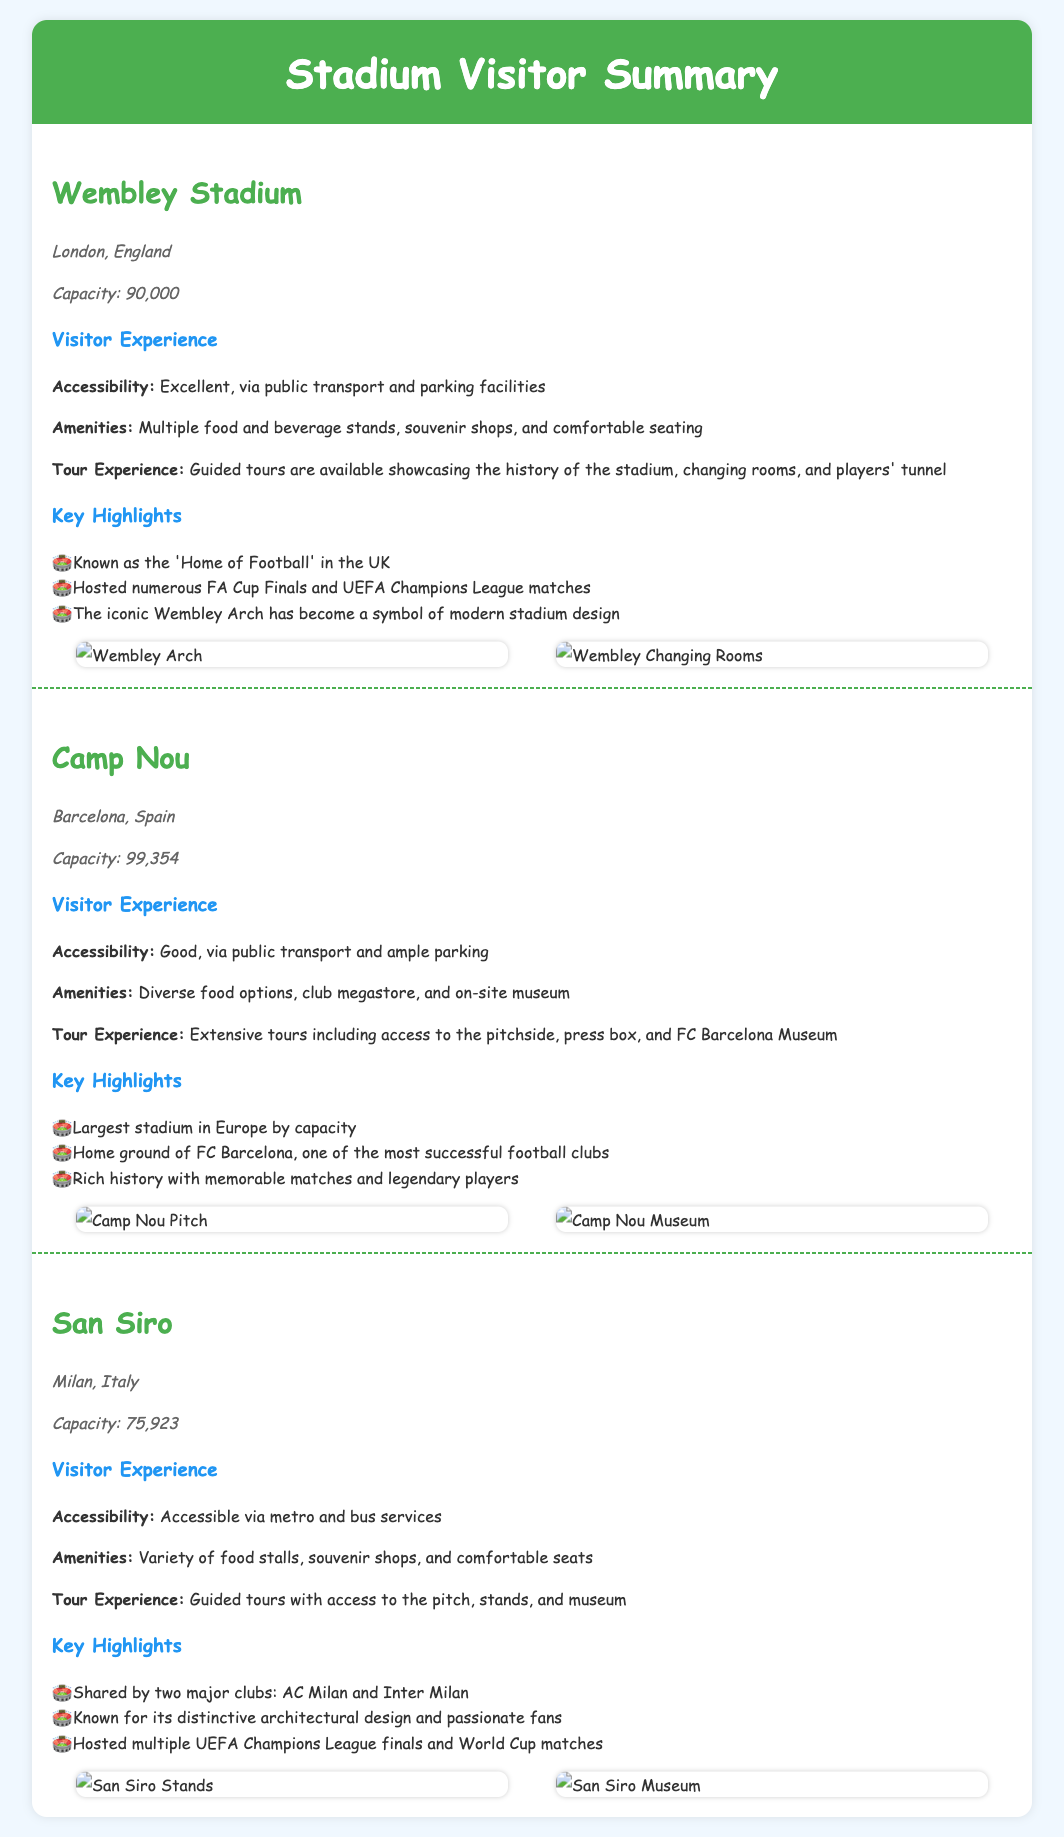What is the capacity of Wembley Stadium? The capacity of Wembley Stadium is explicitly mentioned as 90,000 in the document.
Answer: 90,000 Where is Camp Nou located? The location of Camp Nou is specified as Barcelona, Spain in the document.
Answer: Barcelona, Spain How many clubs share the San Siro? The document states that San Siro is shared by two major clubs, AC Milan and Inter Milan.
Answer: Two What is a key highlight of Wembley Stadium? The document lists memorable highlights of Wembley Stadium, emphasizing its status as the 'Home of Football' in the UK.
Answer: Home of Football What is an amenity available at Camp Nou? The document mentions that Camp Nou has a club megastore among its amenities.
Answer: Club megastore What type of tours are available at San Siro? Guided tours are available, allowing access to the pitch, stands, and museum.
Answer: Guided tours What is the accessibility option for Wembley Stadium? The document notes that Wembley Stadium has excellent accessibility via public transport and parking facilities.
Answer: Excellent Which stadium has the largest capacity in Europe? Camp Nou is identified in the document as the largest stadium in Europe by capacity.
Answer: Camp Nou What is the unique architectural feature of San Siro? The document describes San Siro as known for its distinctive architectural design.
Answer: Distinctive architectural design 